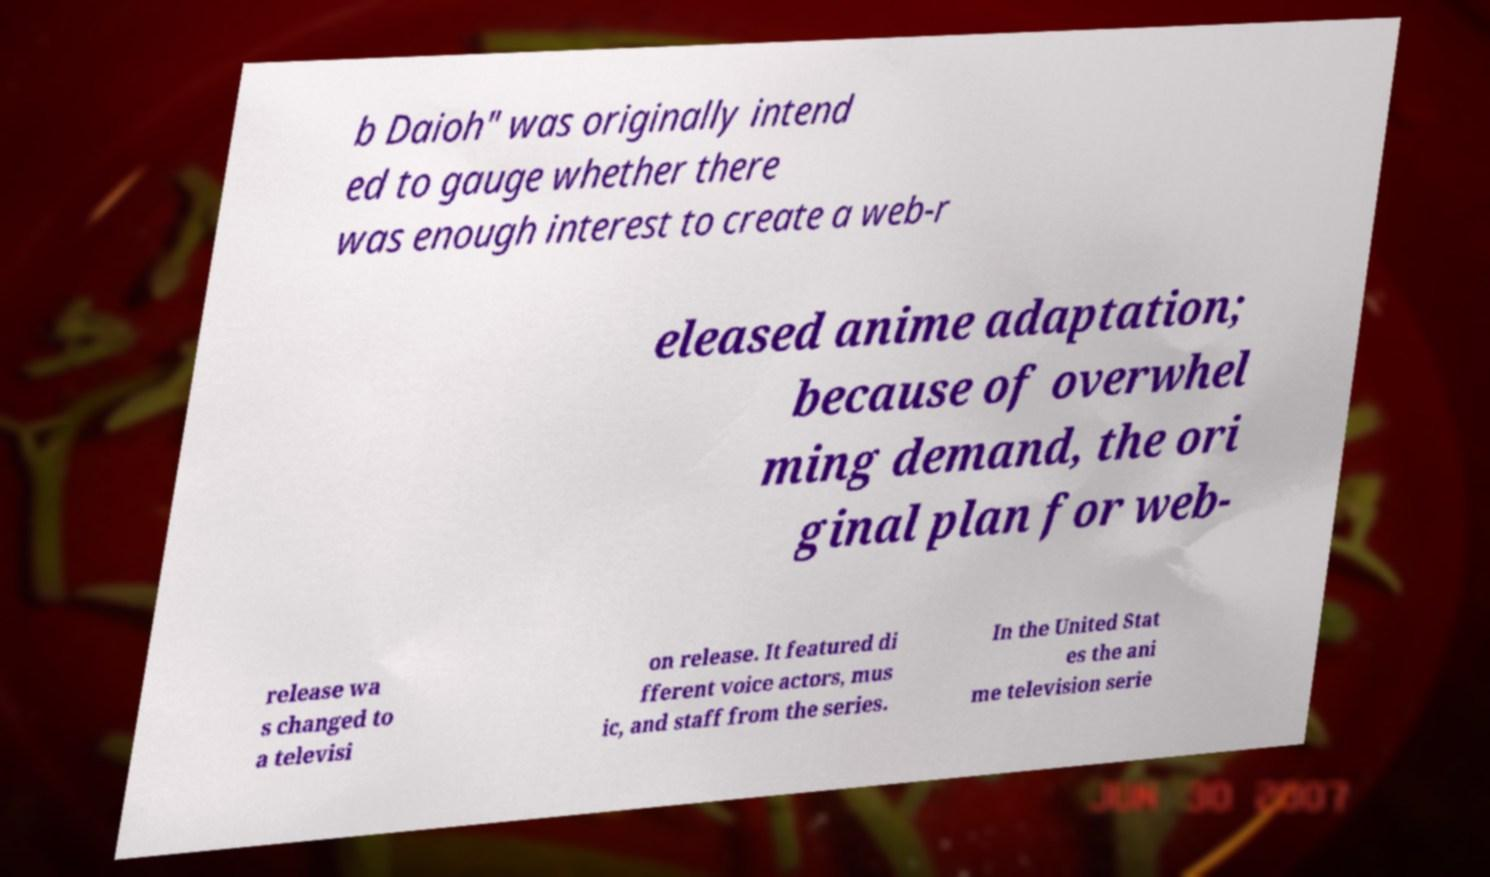Can you accurately transcribe the text from the provided image for me? b Daioh" was originally intend ed to gauge whether there was enough interest to create a web-r eleased anime adaptation; because of overwhel ming demand, the ori ginal plan for web- release wa s changed to a televisi on release. It featured di fferent voice actors, mus ic, and staff from the series. In the United Stat es the ani me television serie 